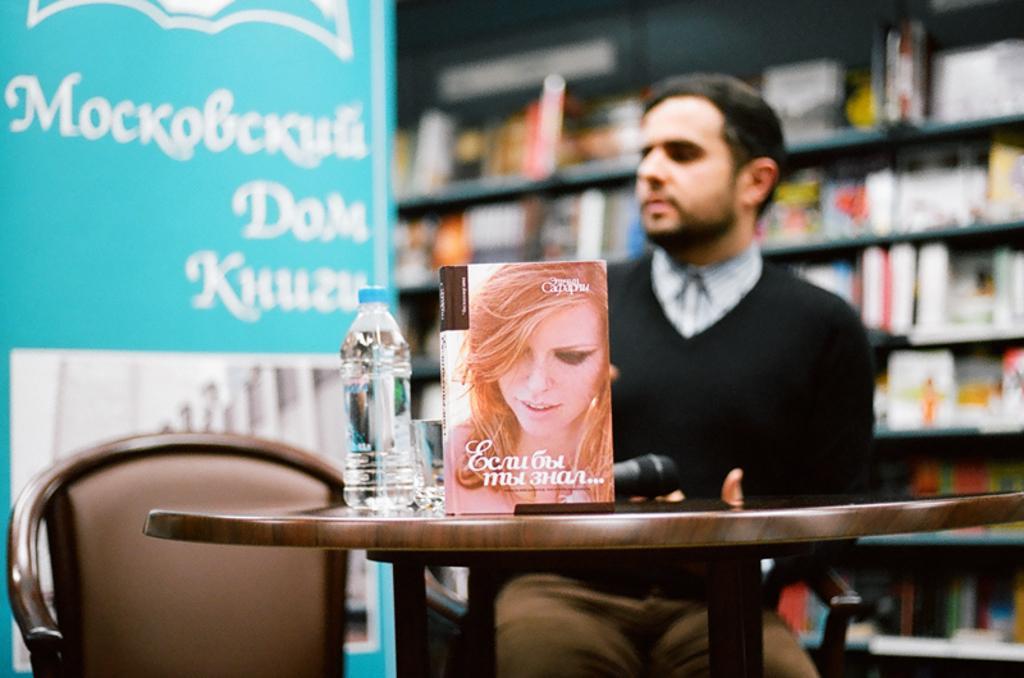Could you give a brief overview of what you see in this image? In this image we can see a person sitting in a chair. In the foreground of the image we can see a bottle, glass, book and a microphone placed on the table. In the left side of the image we can see a banner with some text. On the right side of the image we can see group of books placed in racks. 